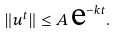<formula> <loc_0><loc_0><loc_500><loc_500>\| u ^ { t } \| \leq A \, \text {e} ^ { - k t } .</formula> 